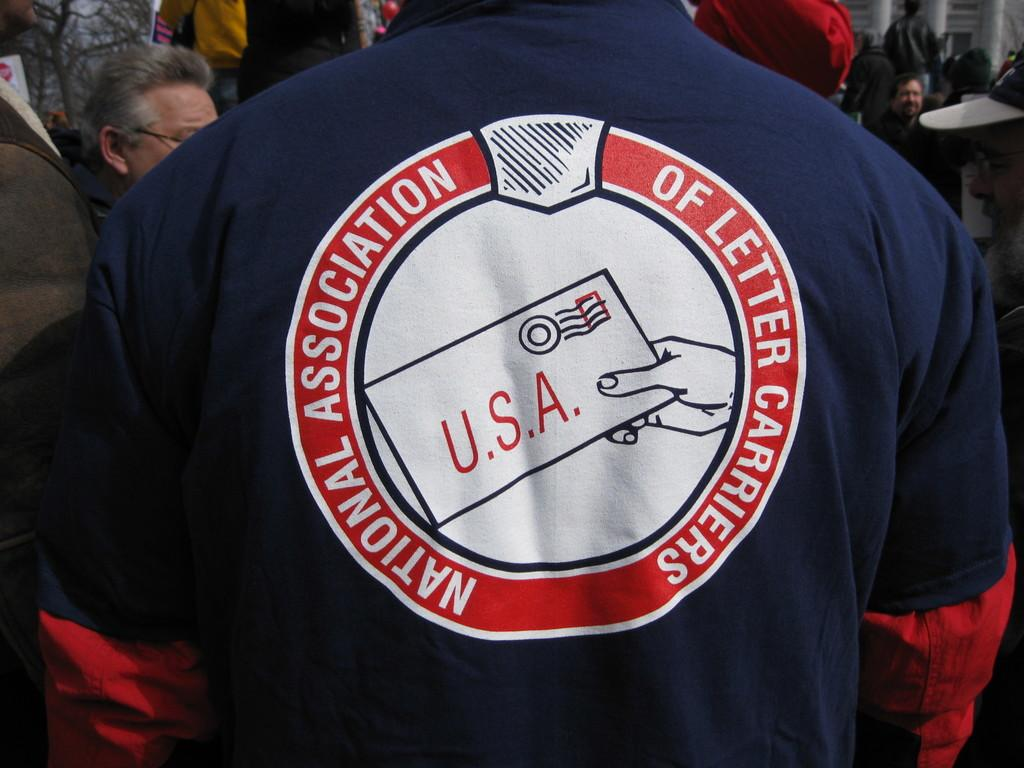Provide a one-sentence caption for the provided image. The back of this person's shirt says "National Association of Letter Carriers" on it. 